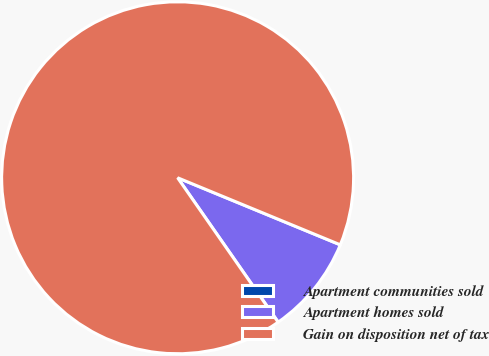Convert chart. <chart><loc_0><loc_0><loc_500><loc_500><pie_chart><fcel>Apartment communities sold<fcel>Apartment homes sold<fcel>Gain on disposition net of tax<nl><fcel>0.01%<fcel>9.09%<fcel>90.9%<nl></chart> 